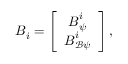<formula> <loc_0><loc_0><loc_500><loc_500>{ { B } _ { i } } = \left [ \begin{array} { c } { { { B } _ { \psi } ^ { i } } } \\ { { { B } _ { \mathcal { B } \psi } ^ { i } } } \end{array} \right ] ,</formula> 